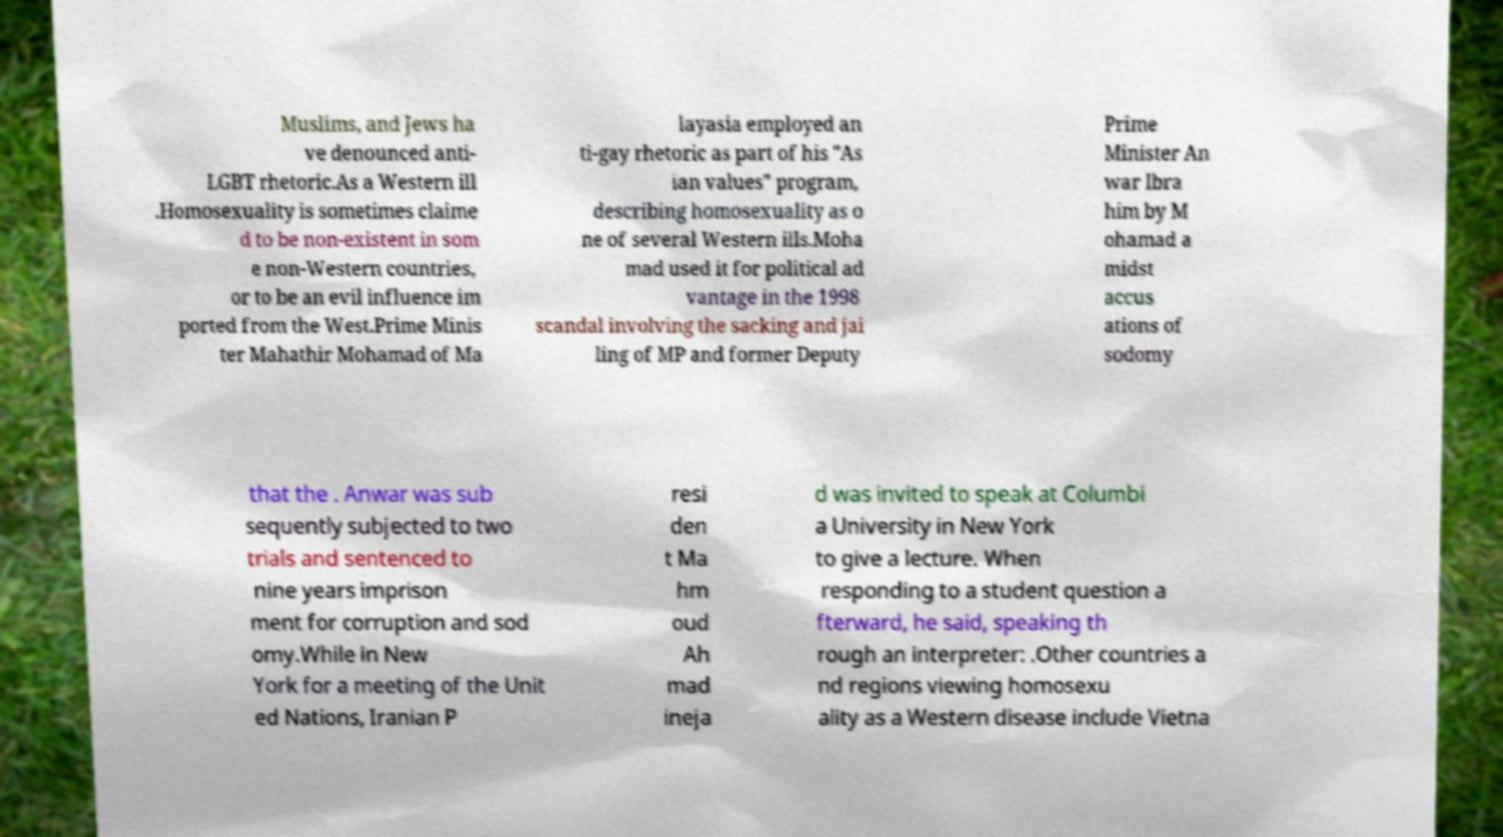Please read and relay the text visible in this image. What does it say? Muslims, and Jews ha ve denounced anti- LGBT rhetoric.As a Western ill .Homosexuality is sometimes claime d to be non-existent in som e non-Western countries, or to be an evil influence im ported from the West.Prime Minis ter Mahathir Mohamad of Ma layasia employed an ti-gay rhetoric as part of his "As ian values" program, describing homosexuality as o ne of several Western ills.Moha mad used it for political ad vantage in the 1998 scandal involving the sacking and jai ling of MP and former Deputy Prime Minister An war Ibra him by M ohamad a midst accus ations of sodomy that the . Anwar was sub sequently subjected to two trials and sentenced to nine years imprison ment for corruption and sod omy.While in New York for a meeting of the Unit ed Nations, Iranian P resi den t Ma hm oud Ah mad ineja d was invited to speak at Columbi a University in New York to give a lecture. When responding to a student question a fterward, he said, speaking th rough an interpreter: .Other countries a nd regions viewing homosexu ality as a Western disease include Vietna 